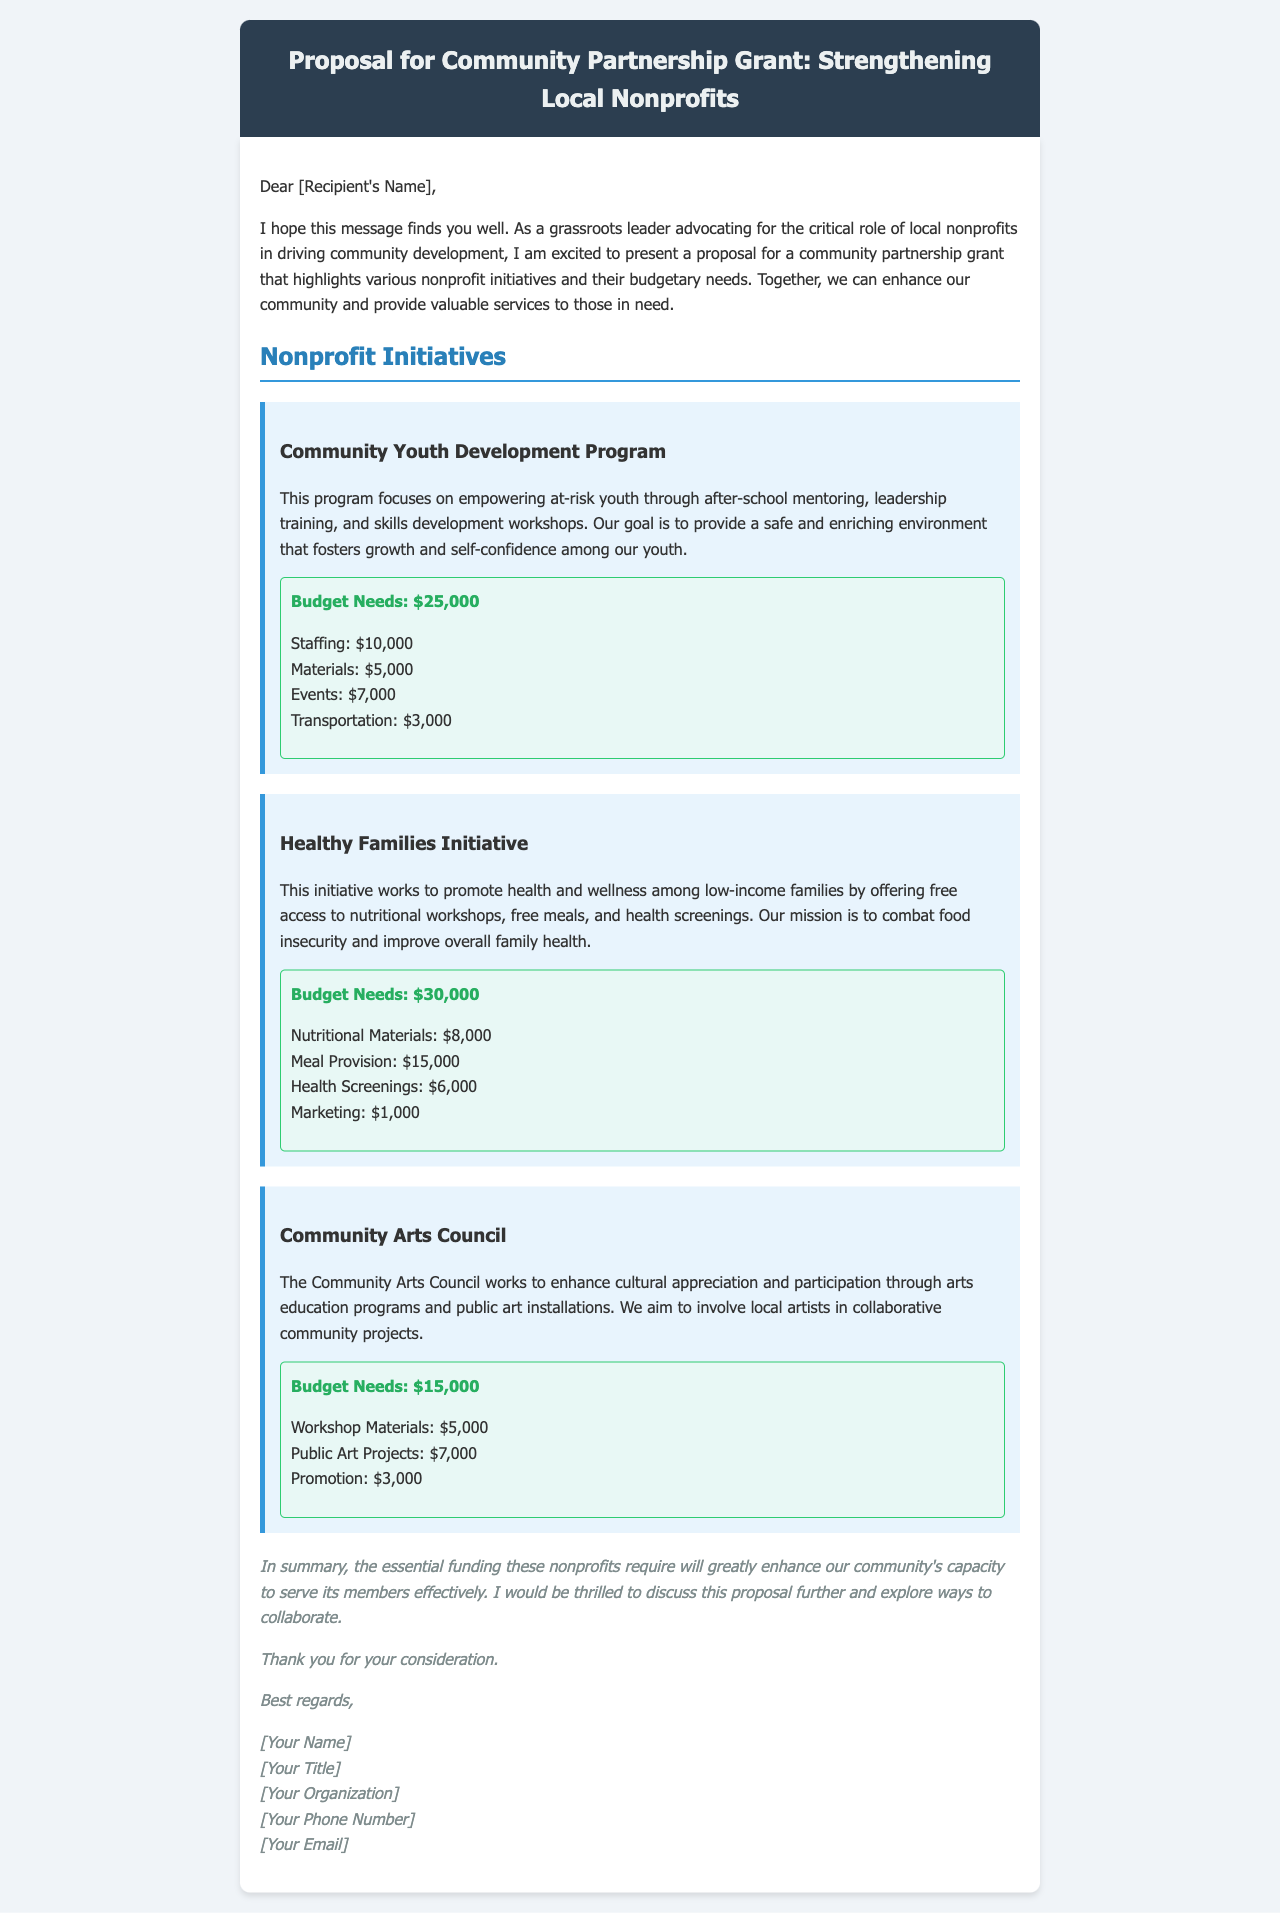What is the proposal for? The proposal aims to strengthen local nonprofits through a community partnership grant.
Answer: Community Partnership Grant What is the budget need for the Community Youth Development Program? The document states that the Community Youth Development Program requires $25,000 in total budget needs.
Answer: $25,000 What initiative focuses on promoting health and wellness among low-income families? The Healthy Families Initiative specifically addresses health and wellness for low-income families.
Answer: Healthy Families Initiative How much is allocated for meal provision in the Healthy Families Initiative? The budget for meal provision within the Healthy Families Initiative is specified as $15,000.
Answer: $15,000 What is the total budget need for the Community Arts Council? The total budget need specified for the Community Arts Council is $15,000.
Answer: $15,000 Which program includes after-school mentoring? The Community Youth Development Program includes after-school mentoring as part of its initiatives.
Answer: Community Youth Development Program What is the total amount requested for the Healthy Families Initiative's health screenings? Health screenings are budgeted at $6,000 within the Healthy Families Initiative.
Answer: $6,000 What type of document is this? This is a proposal document outlining a grant request for community partnership.
Answer: Proposal Who is the author of the proposal? The author's name is indicated as [Your Name] in the closing section of the document.
Answer: [Your Name] 